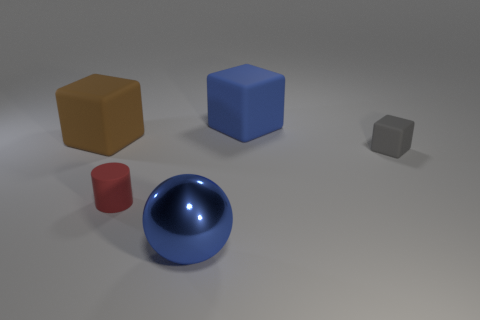Add 2 cyan matte cylinders. How many objects exist? 7 Subtract all cylinders. How many objects are left? 4 Add 1 cylinders. How many cylinders exist? 2 Subtract 0 gray spheres. How many objects are left? 5 Subtract all green metal balls. Subtract all large brown matte cubes. How many objects are left? 4 Add 5 metal balls. How many metal balls are left? 6 